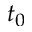Convert formula to latex. <formula><loc_0><loc_0><loc_500><loc_500>t _ { 0 }</formula> 